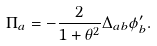<formula> <loc_0><loc_0><loc_500><loc_500>\Pi _ { a } = - \frac { 2 } { 1 + \theta ^ { 2 } } \Delta _ { a b } \phi ^ { \prime } _ { b } .</formula> 